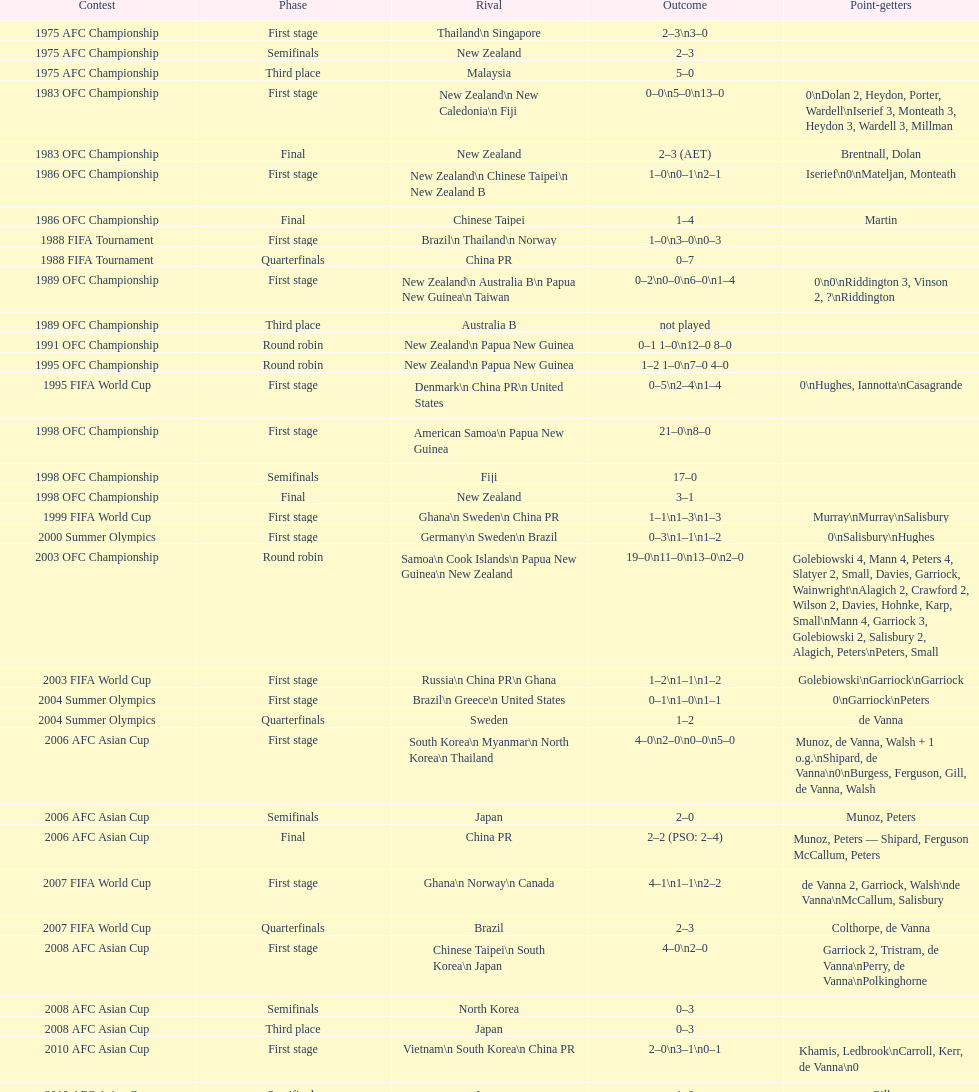Who was the last opponent this team faced in the 2010 afc asian cup? North Korea. 